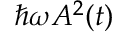<formula> <loc_0><loc_0><loc_500><loc_500>\hslash \omega A ^ { 2 } ( t )</formula> 